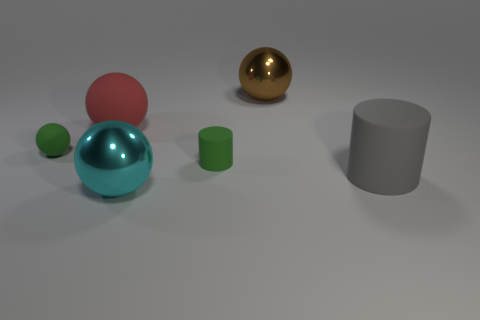What color is the big ball in front of the large matte thing to the right of the shiny thing on the left side of the brown metallic object? The large ball situated in front of the cylindrical matte object, on the right side of the reflective blue ball, and to the left of the brown spherical object, is pink in color. 